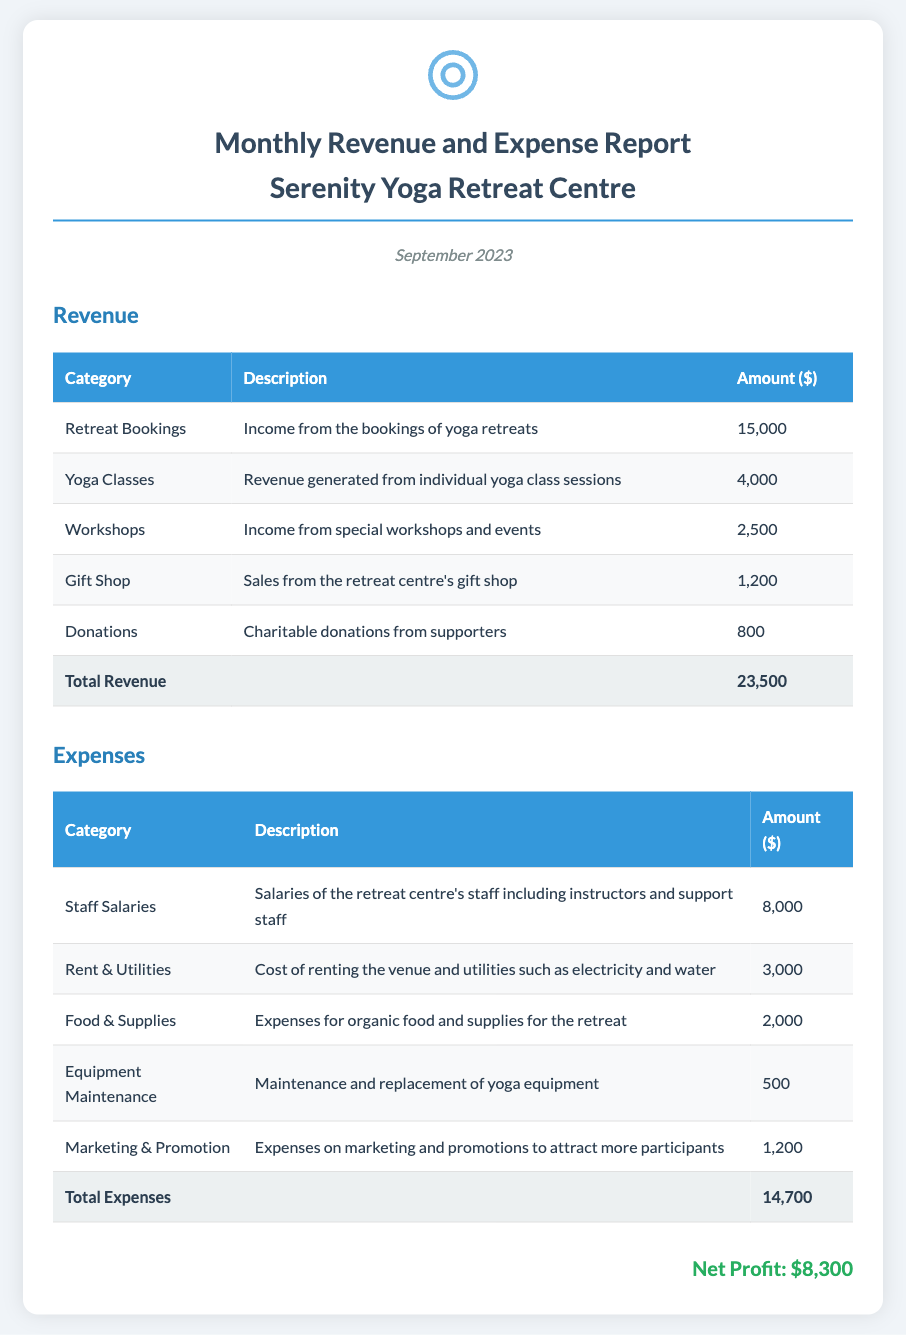what is the total revenue? The total revenue is the sum of all revenue sources in the document, which amounts to $15,000 from Retreat Bookings, $4,000 from Yoga Classes, $2,500 from Workshops, $1,200 from Gift Shop, and $800 from Donations, totaling $23,500.
Answer: $23,500 what is the amount from Yoga Classes? The amount generated from Yoga Classes is specified in the document under its respective category.
Answer: $4,000 what was the highest revenue category? The highest revenue category can be identified by comparing the individual amounts listed for each revenue source.
Answer: Retreat Bookings how much did the centre spend on Staff Salaries? The amount spent on Staff Salaries can be found under the Expenses section of the document.
Answer: $8,000 what is the total expenses amount? The total expenses amount is calculated by adding all the costs listed in the Expenses section, which sums to $14,700.
Answer: $14,700 what is the net profit? The net profit is calculated as total revenue minus total expenses, which results in $8,300.
Answer: $8,300 how much was spent on Food & Supplies? The amount spent on Food & Supplies is indicated in the Expenses table provided in the document.
Answer: $2,000 which month does the report cover? The specific month that the report is covering is stated in the document's heading.
Answer: September 2023 what is the description for Donations? The description for Donations is presented in the context of revenue sources under the respective category.
Answer: Charitable donations from supporters 